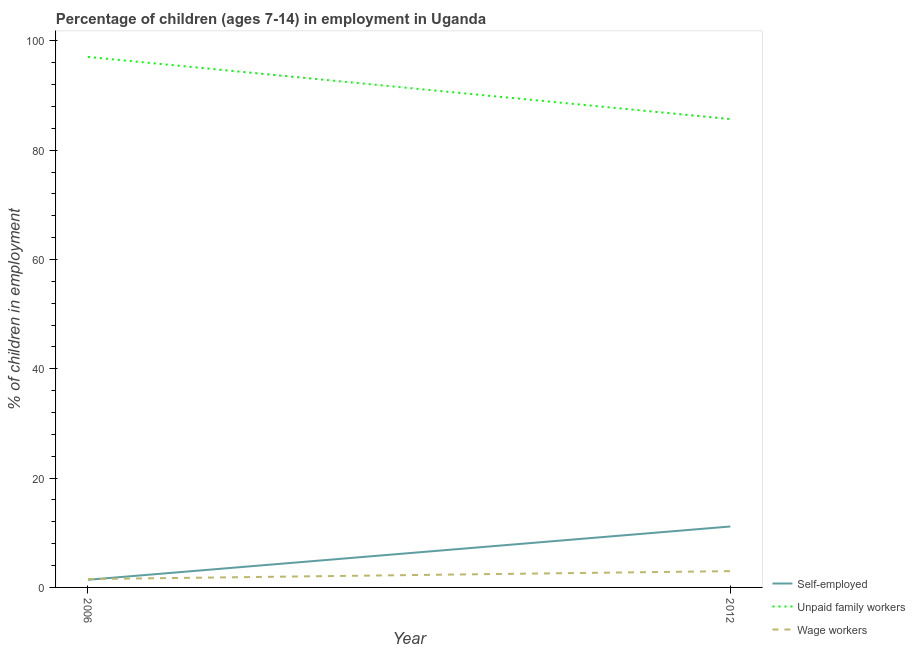How many different coloured lines are there?
Your response must be concise. 3. Does the line corresponding to percentage of children employed as unpaid family workers intersect with the line corresponding to percentage of self employed children?
Provide a succinct answer. No. What is the percentage of self employed children in 2012?
Ensure brevity in your answer.  11.15. Across all years, what is the maximum percentage of self employed children?
Provide a short and direct response. 11.15. Across all years, what is the minimum percentage of children employed as unpaid family workers?
Offer a terse response. 85.7. In which year was the percentage of children employed as unpaid family workers minimum?
Offer a terse response. 2012. What is the total percentage of children employed as unpaid family workers in the graph?
Your response must be concise. 182.77. What is the difference between the percentage of self employed children in 2006 and that in 2012?
Your response must be concise. -9.75. What is the difference between the percentage of self employed children in 2012 and the percentage of children employed as unpaid family workers in 2006?
Give a very brief answer. -85.92. What is the average percentage of children employed as unpaid family workers per year?
Offer a terse response. 91.38. In the year 2006, what is the difference between the percentage of children employed as wage workers and percentage of self employed children?
Make the answer very short. 0.13. In how many years, is the percentage of self employed children greater than 76 %?
Offer a terse response. 0. What is the ratio of the percentage of children employed as wage workers in 2006 to that in 2012?
Give a very brief answer. 0.51. Is the percentage of children employed as unpaid family workers in 2006 less than that in 2012?
Your response must be concise. No. In how many years, is the percentage of children employed as unpaid family workers greater than the average percentage of children employed as unpaid family workers taken over all years?
Ensure brevity in your answer.  1. Does the percentage of children employed as unpaid family workers monotonically increase over the years?
Keep it short and to the point. No. Is the percentage of children employed as unpaid family workers strictly greater than the percentage of children employed as wage workers over the years?
Ensure brevity in your answer.  Yes. How many lines are there?
Your response must be concise. 3. How many years are there in the graph?
Provide a short and direct response. 2. Are the values on the major ticks of Y-axis written in scientific E-notation?
Offer a terse response. No. Does the graph contain grids?
Give a very brief answer. No. How are the legend labels stacked?
Keep it short and to the point. Vertical. What is the title of the graph?
Make the answer very short. Percentage of children (ages 7-14) in employment in Uganda. What is the label or title of the Y-axis?
Provide a succinct answer. % of children in employment. What is the % of children in employment of Unpaid family workers in 2006?
Provide a short and direct response. 97.07. What is the % of children in employment of Wage workers in 2006?
Ensure brevity in your answer.  1.53. What is the % of children in employment in Self-employed in 2012?
Your answer should be compact. 11.15. What is the % of children in employment of Unpaid family workers in 2012?
Offer a terse response. 85.7. What is the % of children in employment of Wage workers in 2012?
Ensure brevity in your answer.  2.98. Across all years, what is the maximum % of children in employment of Self-employed?
Ensure brevity in your answer.  11.15. Across all years, what is the maximum % of children in employment in Unpaid family workers?
Offer a very short reply. 97.07. Across all years, what is the maximum % of children in employment of Wage workers?
Your response must be concise. 2.98. Across all years, what is the minimum % of children in employment in Unpaid family workers?
Keep it short and to the point. 85.7. Across all years, what is the minimum % of children in employment of Wage workers?
Provide a succinct answer. 1.53. What is the total % of children in employment of Self-employed in the graph?
Your response must be concise. 12.55. What is the total % of children in employment in Unpaid family workers in the graph?
Offer a terse response. 182.77. What is the total % of children in employment in Wage workers in the graph?
Ensure brevity in your answer.  4.51. What is the difference between the % of children in employment of Self-employed in 2006 and that in 2012?
Give a very brief answer. -9.75. What is the difference between the % of children in employment in Unpaid family workers in 2006 and that in 2012?
Your answer should be very brief. 11.37. What is the difference between the % of children in employment in Wage workers in 2006 and that in 2012?
Keep it short and to the point. -1.45. What is the difference between the % of children in employment of Self-employed in 2006 and the % of children in employment of Unpaid family workers in 2012?
Your response must be concise. -84.3. What is the difference between the % of children in employment of Self-employed in 2006 and the % of children in employment of Wage workers in 2012?
Your answer should be compact. -1.58. What is the difference between the % of children in employment of Unpaid family workers in 2006 and the % of children in employment of Wage workers in 2012?
Your answer should be very brief. 94.09. What is the average % of children in employment in Self-employed per year?
Your response must be concise. 6.28. What is the average % of children in employment in Unpaid family workers per year?
Keep it short and to the point. 91.39. What is the average % of children in employment in Wage workers per year?
Give a very brief answer. 2.25. In the year 2006, what is the difference between the % of children in employment of Self-employed and % of children in employment of Unpaid family workers?
Your answer should be compact. -95.67. In the year 2006, what is the difference between the % of children in employment in Self-employed and % of children in employment in Wage workers?
Your response must be concise. -0.13. In the year 2006, what is the difference between the % of children in employment in Unpaid family workers and % of children in employment in Wage workers?
Provide a succinct answer. 95.54. In the year 2012, what is the difference between the % of children in employment of Self-employed and % of children in employment of Unpaid family workers?
Your answer should be very brief. -74.55. In the year 2012, what is the difference between the % of children in employment in Self-employed and % of children in employment in Wage workers?
Give a very brief answer. 8.17. In the year 2012, what is the difference between the % of children in employment of Unpaid family workers and % of children in employment of Wage workers?
Offer a terse response. 82.72. What is the ratio of the % of children in employment of Self-employed in 2006 to that in 2012?
Give a very brief answer. 0.13. What is the ratio of the % of children in employment in Unpaid family workers in 2006 to that in 2012?
Ensure brevity in your answer.  1.13. What is the ratio of the % of children in employment in Wage workers in 2006 to that in 2012?
Provide a short and direct response. 0.51. What is the difference between the highest and the second highest % of children in employment in Self-employed?
Ensure brevity in your answer.  9.75. What is the difference between the highest and the second highest % of children in employment of Unpaid family workers?
Ensure brevity in your answer.  11.37. What is the difference between the highest and the second highest % of children in employment of Wage workers?
Your answer should be compact. 1.45. What is the difference between the highest and the lowest % of children in employment of Self-employed?
Your response must be concise. 9.75. What is the difference between the highest and the lowest % of children in employment in Unpaid family workers?
Your answer should be very brief. 11.37. What is the difference between the highest and the lowest % of children in employment of Wage workers?
Your answer should be compact. 1.45. 